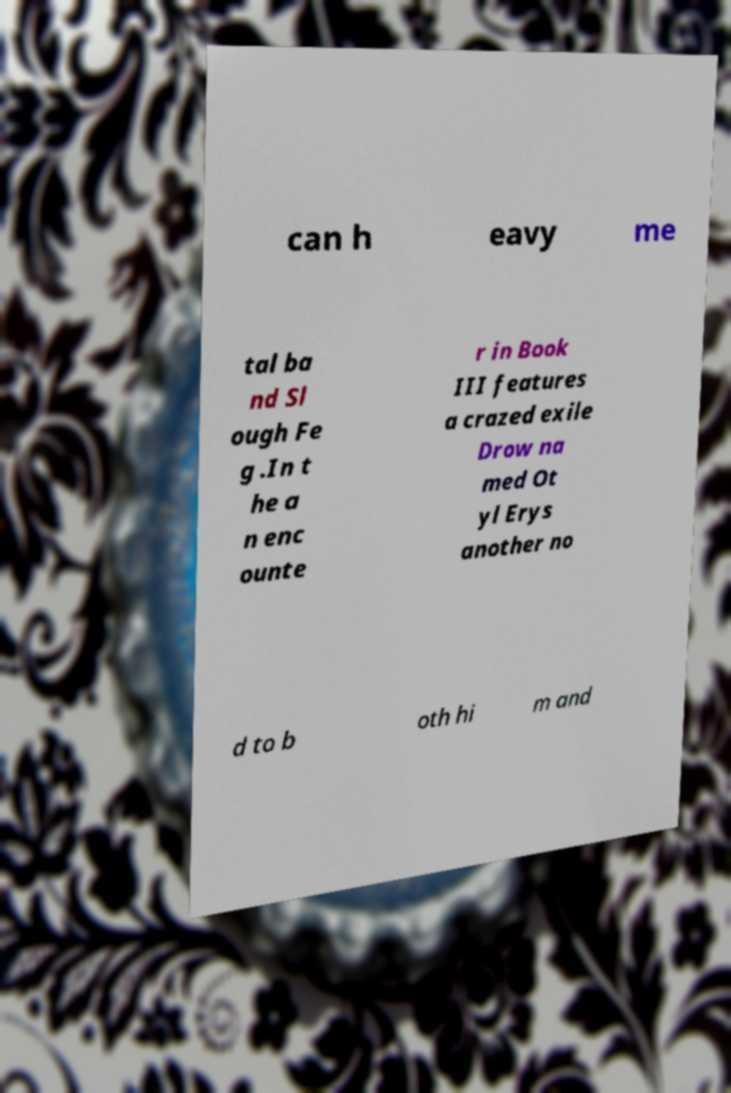Could you extract and type out the text from this image? can h eavy me tal ba nd Sl ough Fe g .In t he a n enc ounte r in Book III features a crazed exile Drow na med Ot yl Erys another no d to b oth hi m and 